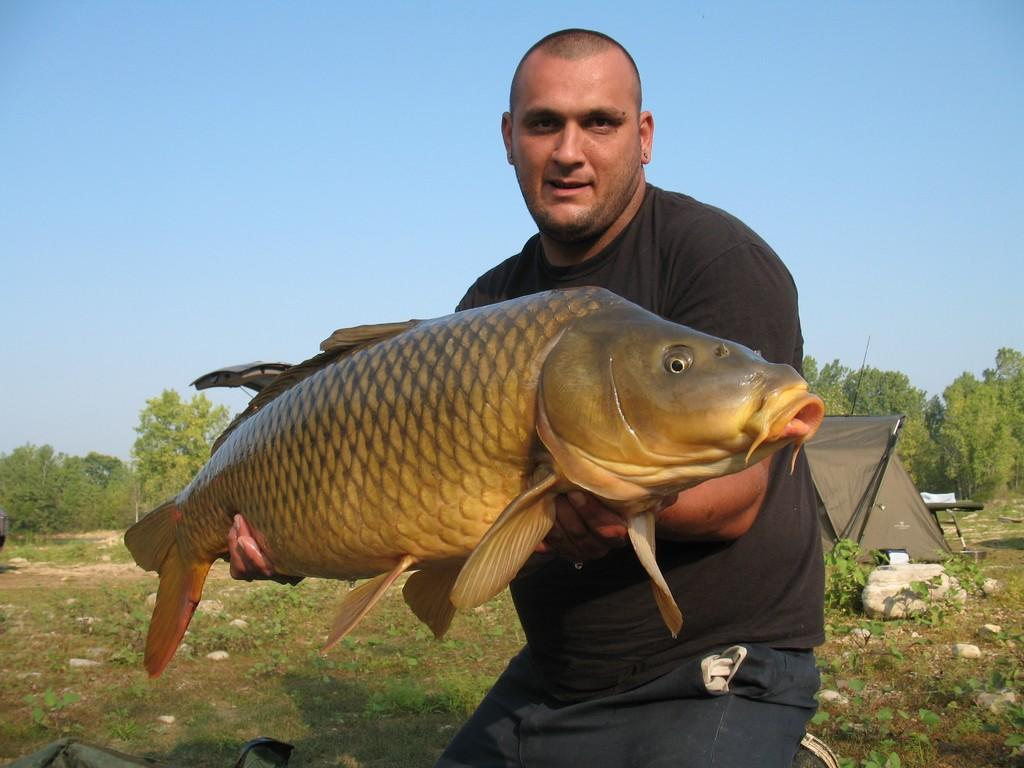What is the person in the image holding? The person is holding a fish in the image. What can be seen in the background of the image? There are trees, a tent, plants, stones, and the sky visible in the background of the image. What type of quill is the person using to catch the fish in the image? There is no quill present in the image; the person is holding a fish with their hands. 